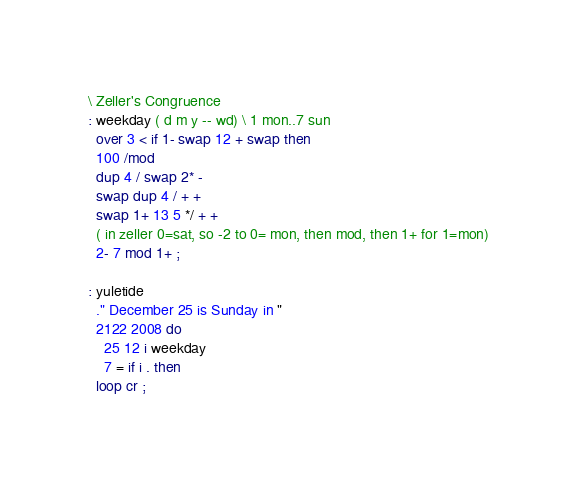<code> <loc_0><loc_0><loc_500><loc_500><_Forth_>\ Zeller's Congruence
: weekday ( d m y -- wd) \ 1 mon..7 sun
  over 3 < if 1- swap 12 + swap then
  100 /mod
  dup 4 / swap 2* -
  swap dup 4 / + +
  swap 1+ 13 5 */ + +
  ( in zeller 0=sat, so -2 to 0= mon, then mod, then 1+ for 1=mon)
  2- 7 mod 1+ ;

: yuletide
  ." December 25 is Sunday in "
  2122 2008 do
    25 12 i weekday
    7 = if i . then
  loop cr ;
</code> 